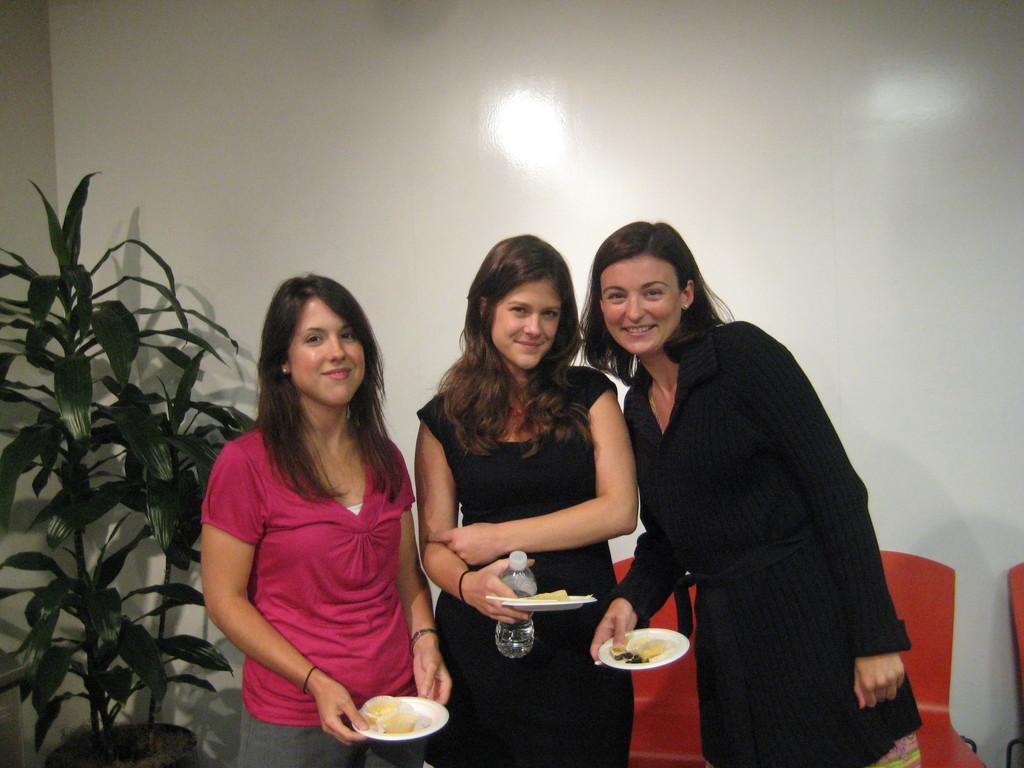Please provide a concise description of this image. In the foreground of this image, there are three women holding platters where a woman is holding a bottle. In the background, there is a plant, wall and chairs. 